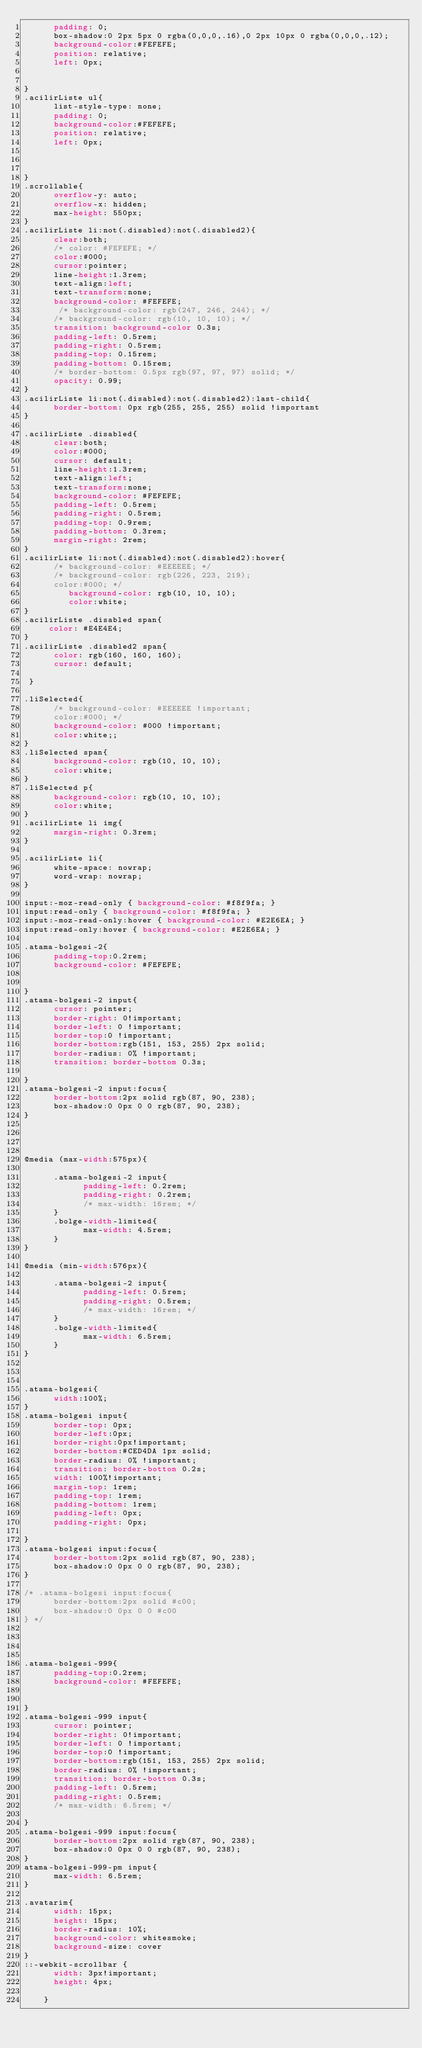<code> <loc_0><loc_0><loc_500><loc_500><_CSS_>      padding: 0;
      box-shadow:0 2px 5px 0 rgba(0,0,0,.16),0 2px 10px 0 rgba(0,0,0,.12);
      background-color:#FEFEFE; 
      position: relative;
      left: 0px;
     

}
.acilirListe ul{      
      list-style-type: none;
      padding: 0;
      background-color:#FEFEFE;
      position: relative;
      left: 0px;



}
.scrollable{
      overflow-y: auto;
      overflow-x: hidden;
      max-height: 550px;
}
.acilirListe li:not(.disabled):not(.disabled2){
      clear:both;
      /* color: #FEFEFE; */
      color:#000;
      cursor:pointer;
      line-height:1.3rem;
      text-align:left;
      text-transform:none;
      background-color: #FEFEFE;
       /* background-color: rgb(247, 246, 244); */
      /* background-color: rgb(10, 10, 10); */
      transition: background-color 0.3s;
      padding-left: 0.5rem;
      padding-right: 0.5rem;
      padding-top: 0.15rem;
      padding-bottom: 0.15rem;
      /* border-bottom: 0.5px rgb(97, 97, 97) solid; */
      opacity: 0.99;
}
.acilirListe li:not(.disabled):not(.disabled2):last-child{
      border-bottom: 0px rgb(255, 255, 255) solid !important
}

.acilirListe .disabled{
      clear:both;
      color:#000;
      cursor: default;
      line-height:1.3rem;
      text-align:left;
      text-transform:none;
      background-color: #FEFEFE;
      padding-left: 0.5rem;
      padding-right: 0.5rem;
      padding-top: 0.9rem;
      padding-bottom: 0.3rem;
      margin-right: 2rem;
}
.acilirListe li:not(.disabled):not(.disabled2):hover{
      /* background-color: #EEEEEE; */
      /* background-color: rgb(226, 223, 219);
      color:#000; */
         background-color: rgb(10, 10, 10);
         color:white;
}
.acilirListe .disabled span{
     color: #E4E4E4;    
}
.acilirListe .disabled2 span{
      color: rgb(160, 160, 160);
      cursor: default;
 
 }

.liSelected{
      /* background-color: #EEEEEE !important;
      color:#000; */
      background-color: #000 !important;
      color:white;;
}
.liSelected span{
      background-color: rgb(10, 10, 10);
      color:white;
}
.liSelected p{
      background-color: rgb(10, 10, 10);
      color:white;
}
.acilirListe li img{
      margin-right: 0.3rem;
}

.acilirListe li{
      white-space: nowrap;
      word-wrap: nowrap;
}

input:-moz-read-only { background-color: #f8f9fa; } 
input:read-only { background-color: #f8f9fa; }
input:-moz-read-only:hover { background-color: #E2E6EA; } 
input:read-only:hover { background-color: #E2E6EA; }

.atama-bolgesi-2{
      padding-top:0.2rem;
      background-color: #FEFEFE;
   
      
}
.atama-bolgesi-2 input{
      cursor: pointer;
      border-right: 0!important;
      border-left: 0 !important;
      border-top:0 !important;
      border-bottom:rgb(151, 153, 255) 2px solid;       
      border-radius: 0% !important;
      transition: border-bottom 0.3s;

}
.atama-bolgesi-2 input:focus{
      border-bottom:2px solid rgb(87, 90, 238);
      box-shadow:0 0px 0 0 rgb(87, 90, 238);
}




@media (max-width:575px){

      .atama-bolgesi-2 input{
            padding-left: 0.2rem;
            padding-right: 0.2rem;
            /* max-width: 16rem; */
      }
      .bolge-width-limited{
            max-width: 4.5rem;
      }
}

@media (min-width:576px){

      .atama-bolgesi-2 input{
            padding-left: 0.5rem;
            padding-right: 0.5rem;
            /* max-width: 16rem; */
      }
      .bolge-width-limited{
            max-width: 6.5rem;
      }
}



.atama-bolgesi{
      width:100%;
}
.atama-bolgesi input{
      border-top: 0px;
      border-left:0px;
      border-right:0px!important;
      border-bottom:#CED4DA 1px solid;      
      border-radius: 0% !important;
      transition: border-bottom 0.2s;
      width: 100%!important;
      margin-top: 1rem;
      padding-top: 1rem;
      padding-bottom: 1rem;
      padding-left: 0px;
      padding-right: 0px;

}
.atama-bolgesi input:focus{
      border-bottom:2px solid rgb(87, 90, 238);
      box-shadow:0 0px 0 0 rgb(87, 90, 238);
}

/* .atama-bolgesi input:focus{
      border-bottom:2px solid #c00;
      box-shadow:0 0px 0 0 #c00
} */




.atama-bolgesi-999{
      padding-top:0.2rem;
      background-color: #FEFEFE;
   
      
}
.atama-bolgesi-999 input{
      cursor: pointer;
      border-right: 0!important;
      border-left: 0 !important;
      border-top:0 !important;
      border-bottom:rgb(151, 153, 255) 2px solid;       
      border-radius: 0% !important;
      transition: border-bottom 0.3s;
      padding-left: 0.5rem;
      padding-right: 0.5rem;
      /* max-width: 6.5rem; */

}
.atama-bolgesi-999 input:focus{
      border-bottom:2px solid rgb(87, 90, 238);
      box-shadow:0 0px 0 0 rgb(87, 90, 238);
}
atama-bolgesi-999-pm input{
      max-width: 6.5rem;
}

.avatarim{
      width: 15px;
      height: 15px;
      border-radius: 10%;
      background-color: whitesmoke;      
      background-size: cover
}
::-webkit-scrollbar {
      width: 3px!important;
      height: 4px;

    }</code> 